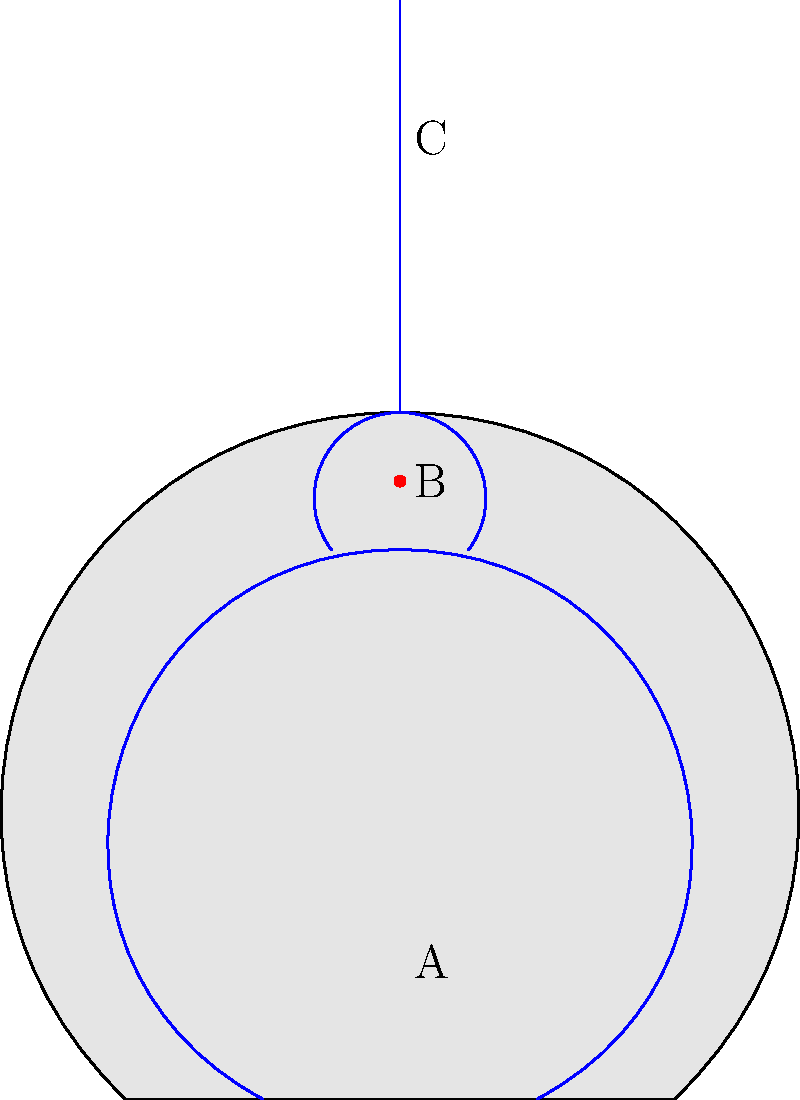Based on the anatomical diagram, which location (A, B, or C) is most likely to represent a deep vein thrombosis (DVT) in a patient recently diagnosed with venous thromboembolism (VTE)? To identify the location of deep vein thrombosis (DVT) in this anatomical diagram, let's follow these steps:

1. Understand DVT: Deep vein thrombosis typically occurs in the deep veins of the legs or pelvis.

2. Analyze the diagram:
   - Point A is located in the lower leg area
   - Point B is in the pelvic region
   - Point C is in the abdominal area

3. Observe the red dot: There's a red dot near point B, which likely represents a blood clot.

4. Consider VTE diagnosis: VTE includes both DVT and pulmonary embolism (PE). A recent VTE diagnosis suggests the presence of a clot, most commonly in the deep veins of the legs or pelvis.

5. Evaluate likelihood:
   - Point A: While DVT can occur in the lower leg, there's no indication of a clot here.
   - Point B: The red dot indicates a clot in the pelvic region, a common site for DVT.
   - Point C: This area represents abdominal veins, which are less common sites for DVT.

6. Conclusion: Based on the presence of the red dot (clot) and the typical locations for DVT, point B is the most likely location for DVT in this patient.
Answer: B 